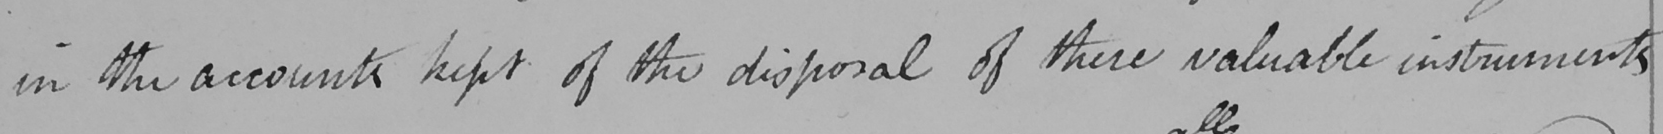Can you read and transcribe this handwriting? in the accounts kept of the disposal of these valuable instruments 